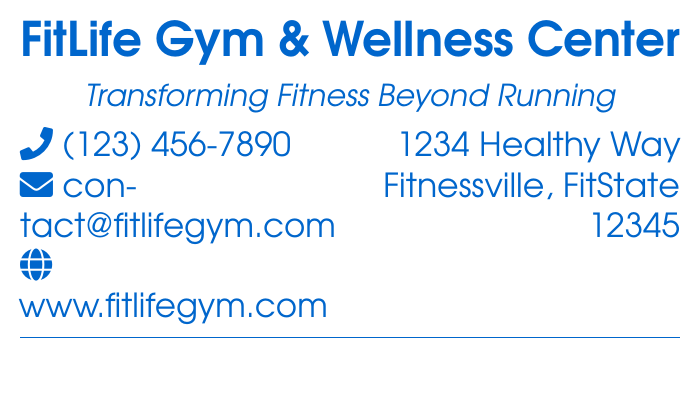what is the name of the gym? The name of the gym is prominently displayed at the top of the document.
Answer: FitLife Gym & Wellness Center what is the gym's contact phone number? The phone number is provided in the contact information section of the card.
Answer: (123) 456-7890 what type of classes does the gym offer? The types of classes offered are listed in a small text section with icons.
Answer: Yoga, Cycling, Weight Training is there a running program offered at this gym? The document explicitly states this information regarding running programs.
Answer: No where is the gym located? The address of the gym is found in the contact information section.
Answer: 1234 Healthy Way, Fitnessville, FitState 12345 what color is used for the gym's name? The color of the gym's name is specified in the color definition in the document.
Answer: Fitblue what does the tagline say? The tagline is a brief phrase that describes the gym's philosophy.
Answer: Transforming Fitness Beyond Running what is the email address for contacting the gym? The email address is provided in the contact section of the card.
Answer: contact@fitlifegym.com what type of font is used for the gym's name? The font family used for the gym's name is indicated in the document.
Answer: Avant 